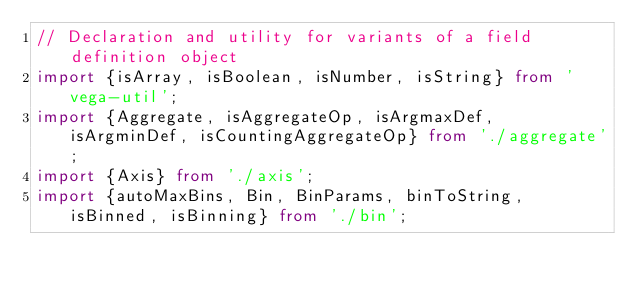Convert code to text. <code><loc_0><loc_0><loc_500><loc_500><_TypeScript_>// Declaration and utility for variants of a field definition object
import {isArray, isBoolean, isNumber, isString} from 'vega-util';
import {Aggregate, isAggregateOp, isArgmaxDef, isArgminDef, isCountingAggregateOp} from './aggregate';
import {Axis} from './axis';
import {autoMaxBins, Bin, BinParams, binToString, isBinned, isBinning} from './bin';</code> 